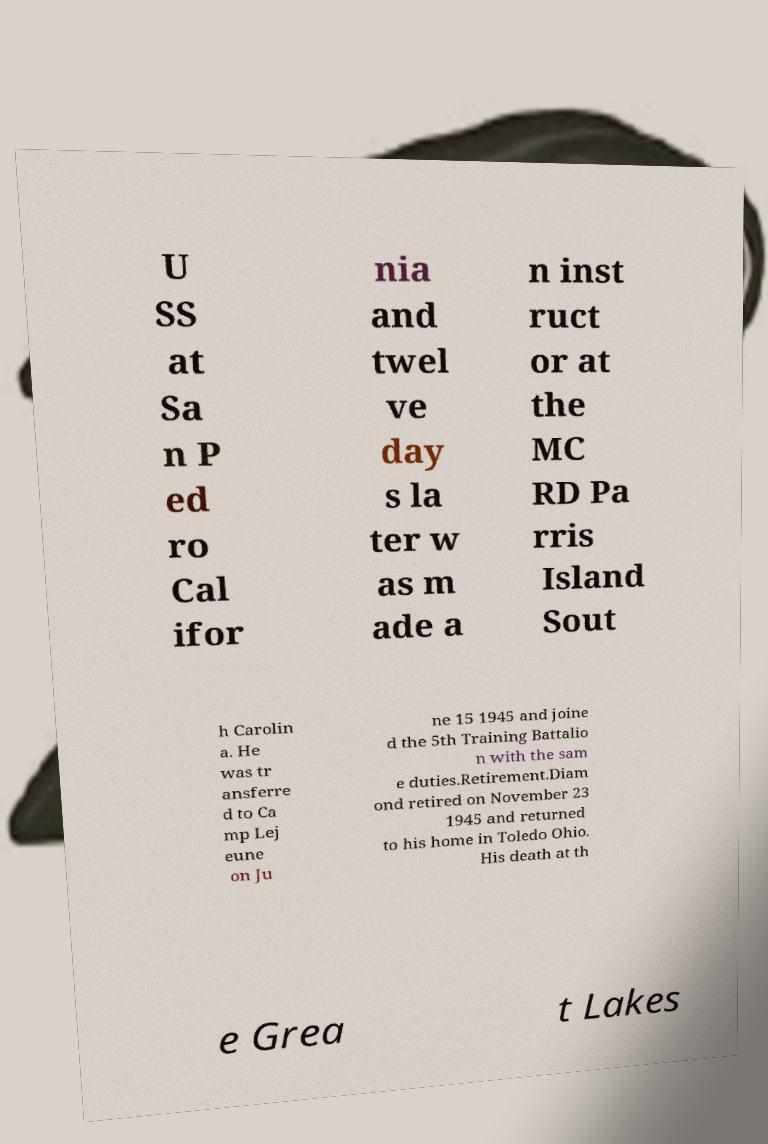Can you accurately transcribe the text from the provided image for me? U SS at Sa n P ed ro Cal ifor nia and twel ve day s la ter w as m ade a n inst ruct or at the MC RD Pa rris Island Sout h Carolin a. He was tr ansferre d to Ca mp Lej eune on Ju ne 15 1945 and joine d the 5th Training Battalio n with the sam e duties.Retirement.Diam ond retired on November 23 1945 and returned to his home in Toledo Ohio. His death at th e Grea t Lakes 